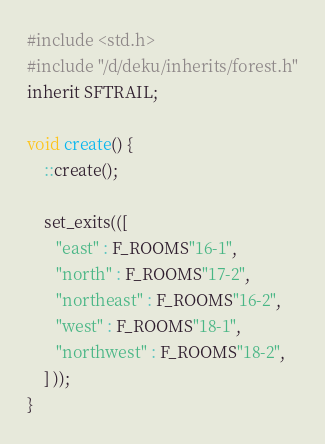<code> <loc_0><loc_0><loc_500><loc_500><_C_>#include <std.h>
#include "/d/deku/inherits/forest.h"
inherit SFTRAIL;

void create() {
    ::create();

    set_exits(([
       "east" : F_ROOMS"16-1",
       "north" : F_ROOMS"17-2",
       "northeast" : F_ROOMS"16-2",
       "west" : F_ROOMS"18-1",
       "northwest" : F_ROOMS"18-2",
    ] ));
}
</code> 